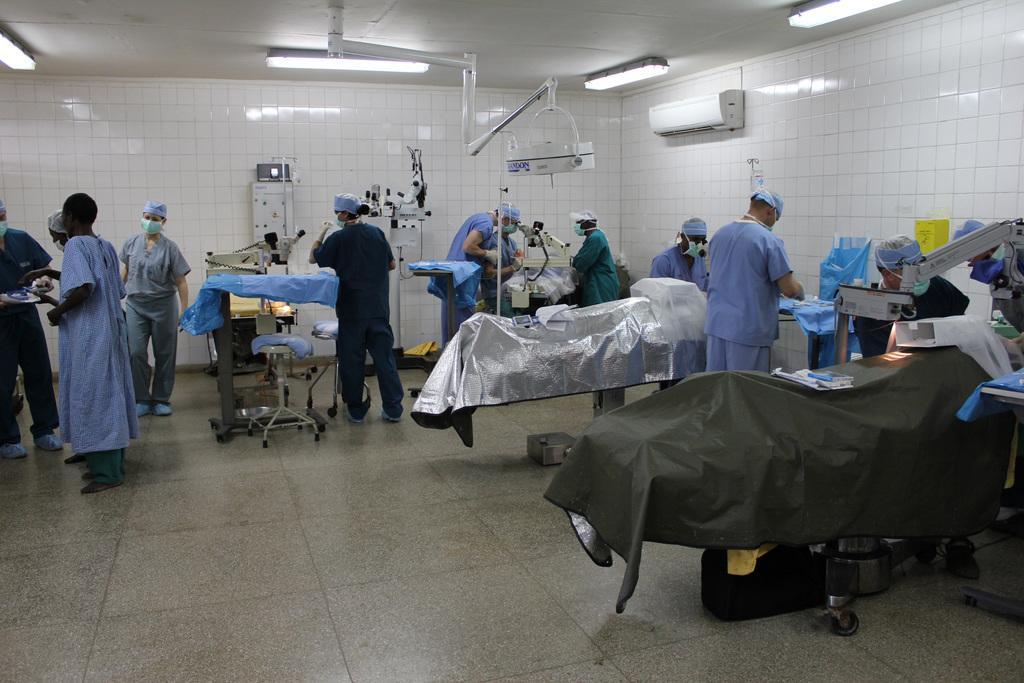Can you describe this image briefly? This is the picture of a room. In this image there are group of people standing and there are beds and stools and there are devices. At the top there are lights and there is an air conditioner. There are tiles on the wall. 